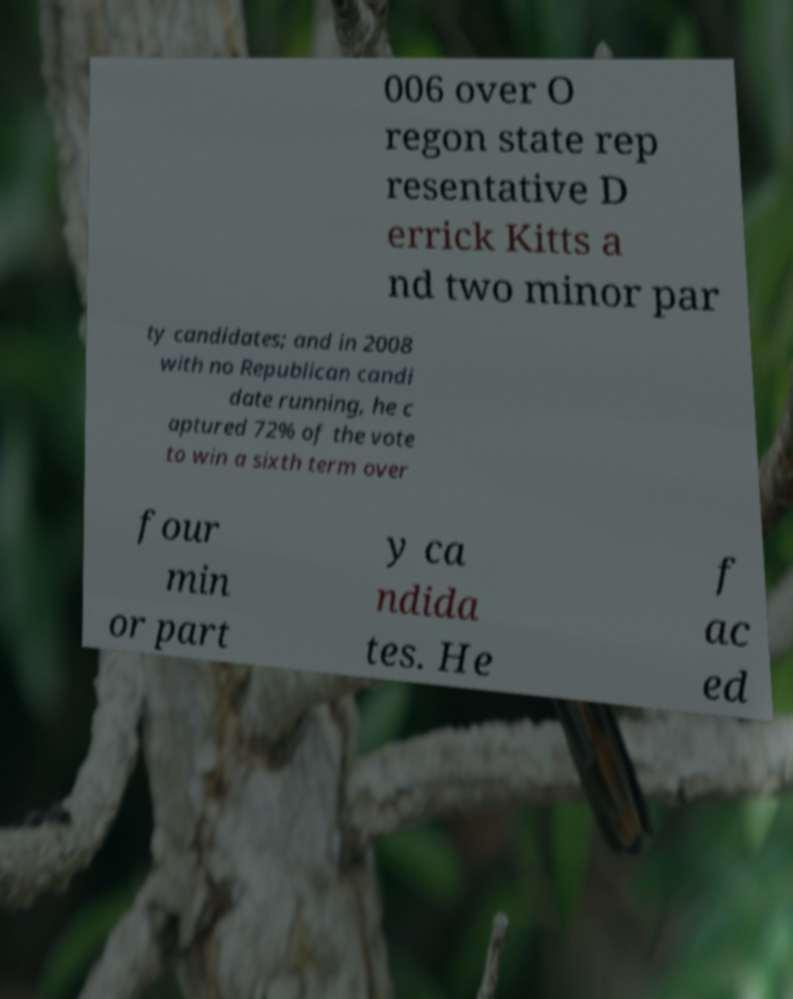Could you extract and type out the text from this image? 006 over O regon state rep resentative D errick Kitts a nd two minor par ty candidates; and in 2008 with no Republican candi date running, he c aptured 72% of the vote to win a sixth term over four min or part y ca ndida tes. He f ac ed 